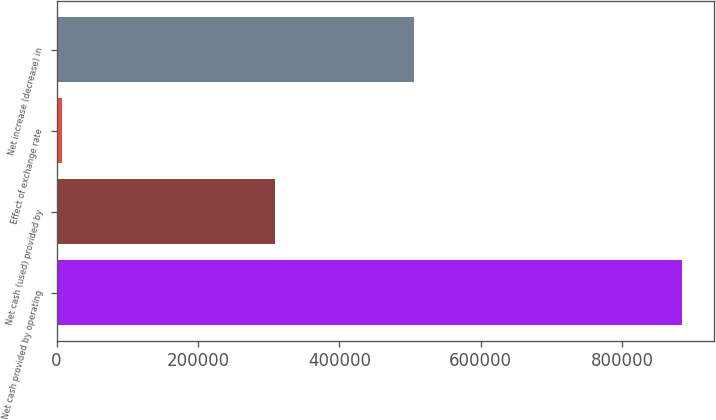Convert chart to OTSL. <chart><loc_0><loc_0><loc_500><loc_500><bar_chart><fcel>Net cash provided by operating<fcel>Net cash (used) provided by<fcel>Effect of exchange rate<fcel>Net increase (decrease) in<nl><fcel>885291<fcel>308944<fcel>7788<fcel>505017<nl></chart> 